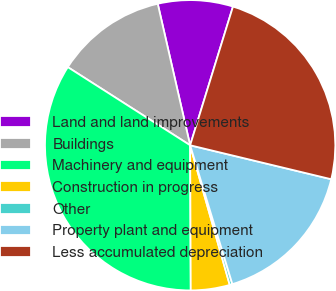<chart> <loc_0><loc_0><loc_500><loc_500><pie_chart><fcel>Land and land improvements<fcel>Buildings<fcel>Machinery and equipment<fcel>Construction in progress<fcel>Other<fcel>Property plant and equipment<fcel>Less accumulated depreciation<nl><fcel>8.35%<fcel>12.37%<fcel>34.11%<fcel>4.33%<fcel>0.3%<fcel>16.54%<fcel>23.99%<nl></chart> 